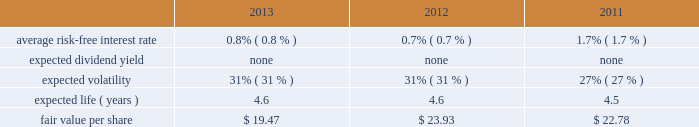Edwards lifesciences corporation notes to consolidated financial statements ( continued ) 12 .
Common stock ( continued ) the company also maintains the nonemployee directors stock incentive compensation program ( the 2018 2018nonemployee directors program 2019 2019 ) .
Under the nonemployee directors program , each nonemployee director may receive annually up to 10000 stock options or 4000 restricted stock units of the company 2019s common stock , or a combination thereof , provided that in no event may the total value of the combined annual award exceed $ 0.2 million .
Additionally , each nonemployee director may elect to receive all or a portion of the annual cash retainer to which the director is otherwise entitled through the issuance of stock options or restricted stock units .
Each option and restricted stock unit award granted in 2011 or prior generally vests in three equal annual installments .
Each option and restricted stock unit award granted after 2011 generally vests after one year .
Upon a director 2019s initial election to the board , the director receives an initial grant of restricted stock units equal to a fair market value on grant date of $ 0.2 million , not to exceed 10000 shares .
These grants vest over three years from the date of grant .
Under the nonemployee directors program , an aggregate of 1.4 million shares of the company 2019s common stock has been authorized for issuance .
The company has an employee stock purchase plan for united states employees and a plan for international employees ( collectively 2018 2018espp 2019 2019 ) .
Under the espp , eligible employees may purchase shares of the company 2019s common stock at 85% ( 85 % ) of the lower of the fair market value of edwards lifesciences common stock on the effective date of subscription or the date of purchase .
Under the espp , employees can authorize the company to withhold up to 12% ( 12 % ) of their compensation for common stock purchases , subject to certain limitations .
The espp is available to all active employees of the company paid from the united states payroll and to eligible employees of the company outside the united states to the extent permitted by local law .
The espp for united states employees is qualified under section 423 of the internal revenue code .
The number of shares of common stock authorized for issuance under the espp was 6.6 million shares .
The fair value of each option award and employee stock purchase subscription is estimated on the date of grant using the black-scholes option valuation model that uses the assumptions noted in the tables .
The risk-free interest rate is estimated using the u.s .
Treasury yield curve and is based on the expected term of the award .
Expected volatility is estimated based on a blend of the weighted-average of the historical volatility of edwards 2019 stock and the implied volatility from traded options on edwards 2019 stock .
The expected term of awards granted is estimated from the vesting period of the award , as well as historical exercise behavior , and represents the period of time that awards granted are expected to be outstanding .
The company uses historical data to estimate forfeitures and has estimated an annual forfeiture rate of 5.1% ( 5.1 % ) .
The black-scholes option pricing model was used with the following weighted-average assumptions for options granted during the following periods : option awards .

What is the percentage change in the fair value per share between 2011 and 2012? 
Computations: ((23.93 - 22.78) / 22.78)
Answer: 0.05048. 